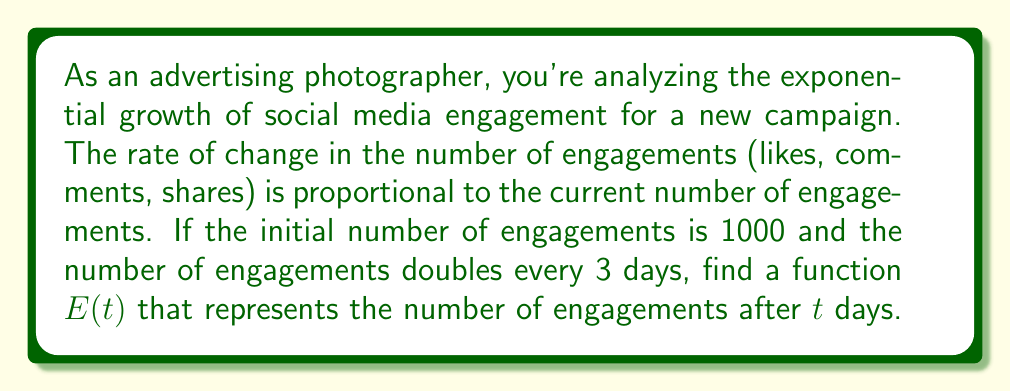Can you solve this math problem? Let's approach this step-by-step:

1) We're dealing with exponential growth, which can be modeled by the differential equation:

   $$\frac{dE}{dt} = kE$$

   where $k$ is the growth constant and $E$ is the number of engagements.

2) We're given that $E(0) = 1000$ (initial condition).

3) We're also told that the number of engagements doubles every 3 days. We can use this to find $k$:

   $$E(3) = 2E(0) = 2(1000) = 2000$$

4) The general solution to the differential equation is:

   $$E(t) = Ce^{kt}$$

   where $C$ is a constant we can find using the initial condition.

5) Using the initial condition:

   $$1000 = Ce^{k(0)} = C$$

   So, $C = 1000$.

6) Now we can use the doubling information to find $k$:

   $$2000 = 1000e^{k(3)}$$
   $$2 = e^{3k}$$
   $$\ln(2) = 3k$$
   $$k = \frac{\ln(2)}{3}$$

7) Therefore, our final function is:

   $$E(t) = 1000e^{\frac{\ln(2)}{3}t}$$

This function represents the number of engagements after $t$ days.
Answer: $$E(t) = 1000e^{\frac{\ln(2)}{3}t}$$ 